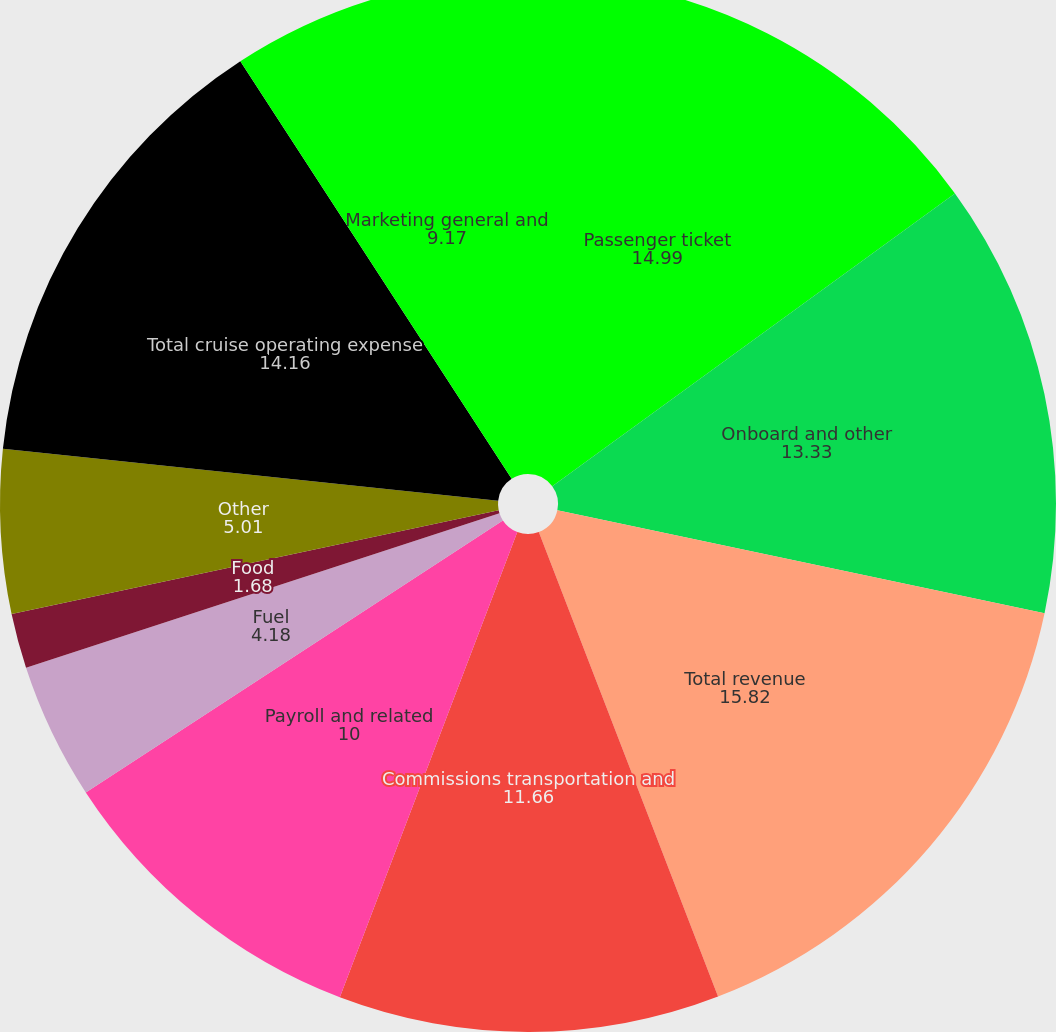Convert chart to OTSL. <chart><loc_0><loc_0><loc_500><loc_500><pie_chart><fcel>Passenger ticket<fcel>Onboard and other<fcel>Total revenue<fcel>Commissions transportation and<fcel>Payroll and related<fcel>Fuel<fcel>Food<fcel>Other<fcel>Total cruise operating expense<fcel>Marketing general and<nl><fcel>14.99%<fcel>13.33%<fcel>15.82%<fcel>11.66%<fcel>10.0%<fcel>4.18%<fcel>1.68%<fcel>5.01%<fcel>14.16%<fcel>9.17%<nl></chart> 